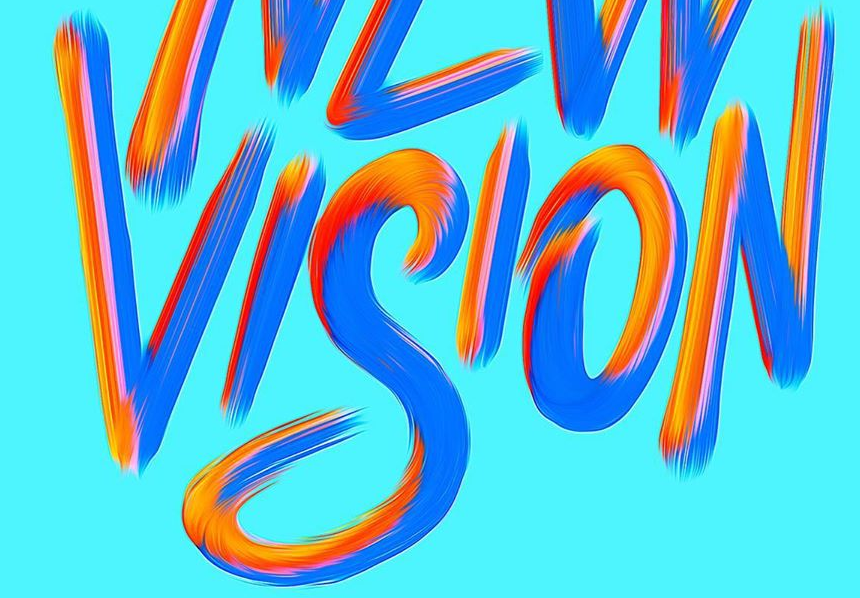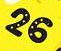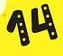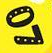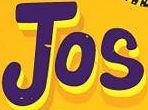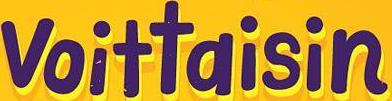What words are shown in these images in order, separated by a semicolon? VISION; 26; 14; 07; Jos; voittaisin 